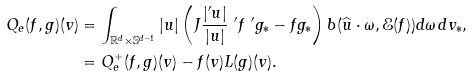<formula> <loc_0><loc_0><loc_500><loc_500>Q _ { e } ( f , g ) ( v ) & = \int _ { \mathbb { R } ^ { d } \times \mathbb { S } ^ { d - 1 } } | u | \left ( J \frac { | ^ { \prime } u | } { | u | } \ ^ { \prime } f \ ^ { \prime } g _ { * } - f g _ { * } \right ) b ( \widehat { u } \cdot \omega , \mathcal { E } ( f ) ) d \omega \, d v _ { * } , \\ & = Q _ { e } ^ { + } ( f , g ) ( v ) - f ( v ) L ( g ) ( v ) .</formula> 